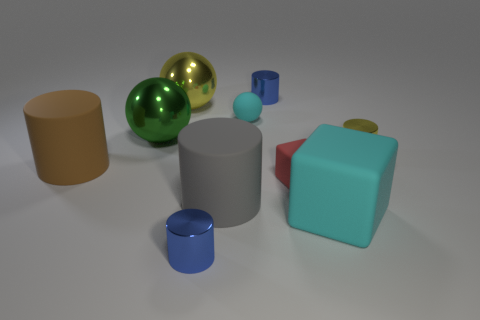Looking at the lighting and shadows, where might the light source be located? Based on the shadows being cast toward the lower right and the highlights on the upper left of the objects, the primary light source appears to be coming from the upper left side of the image. 